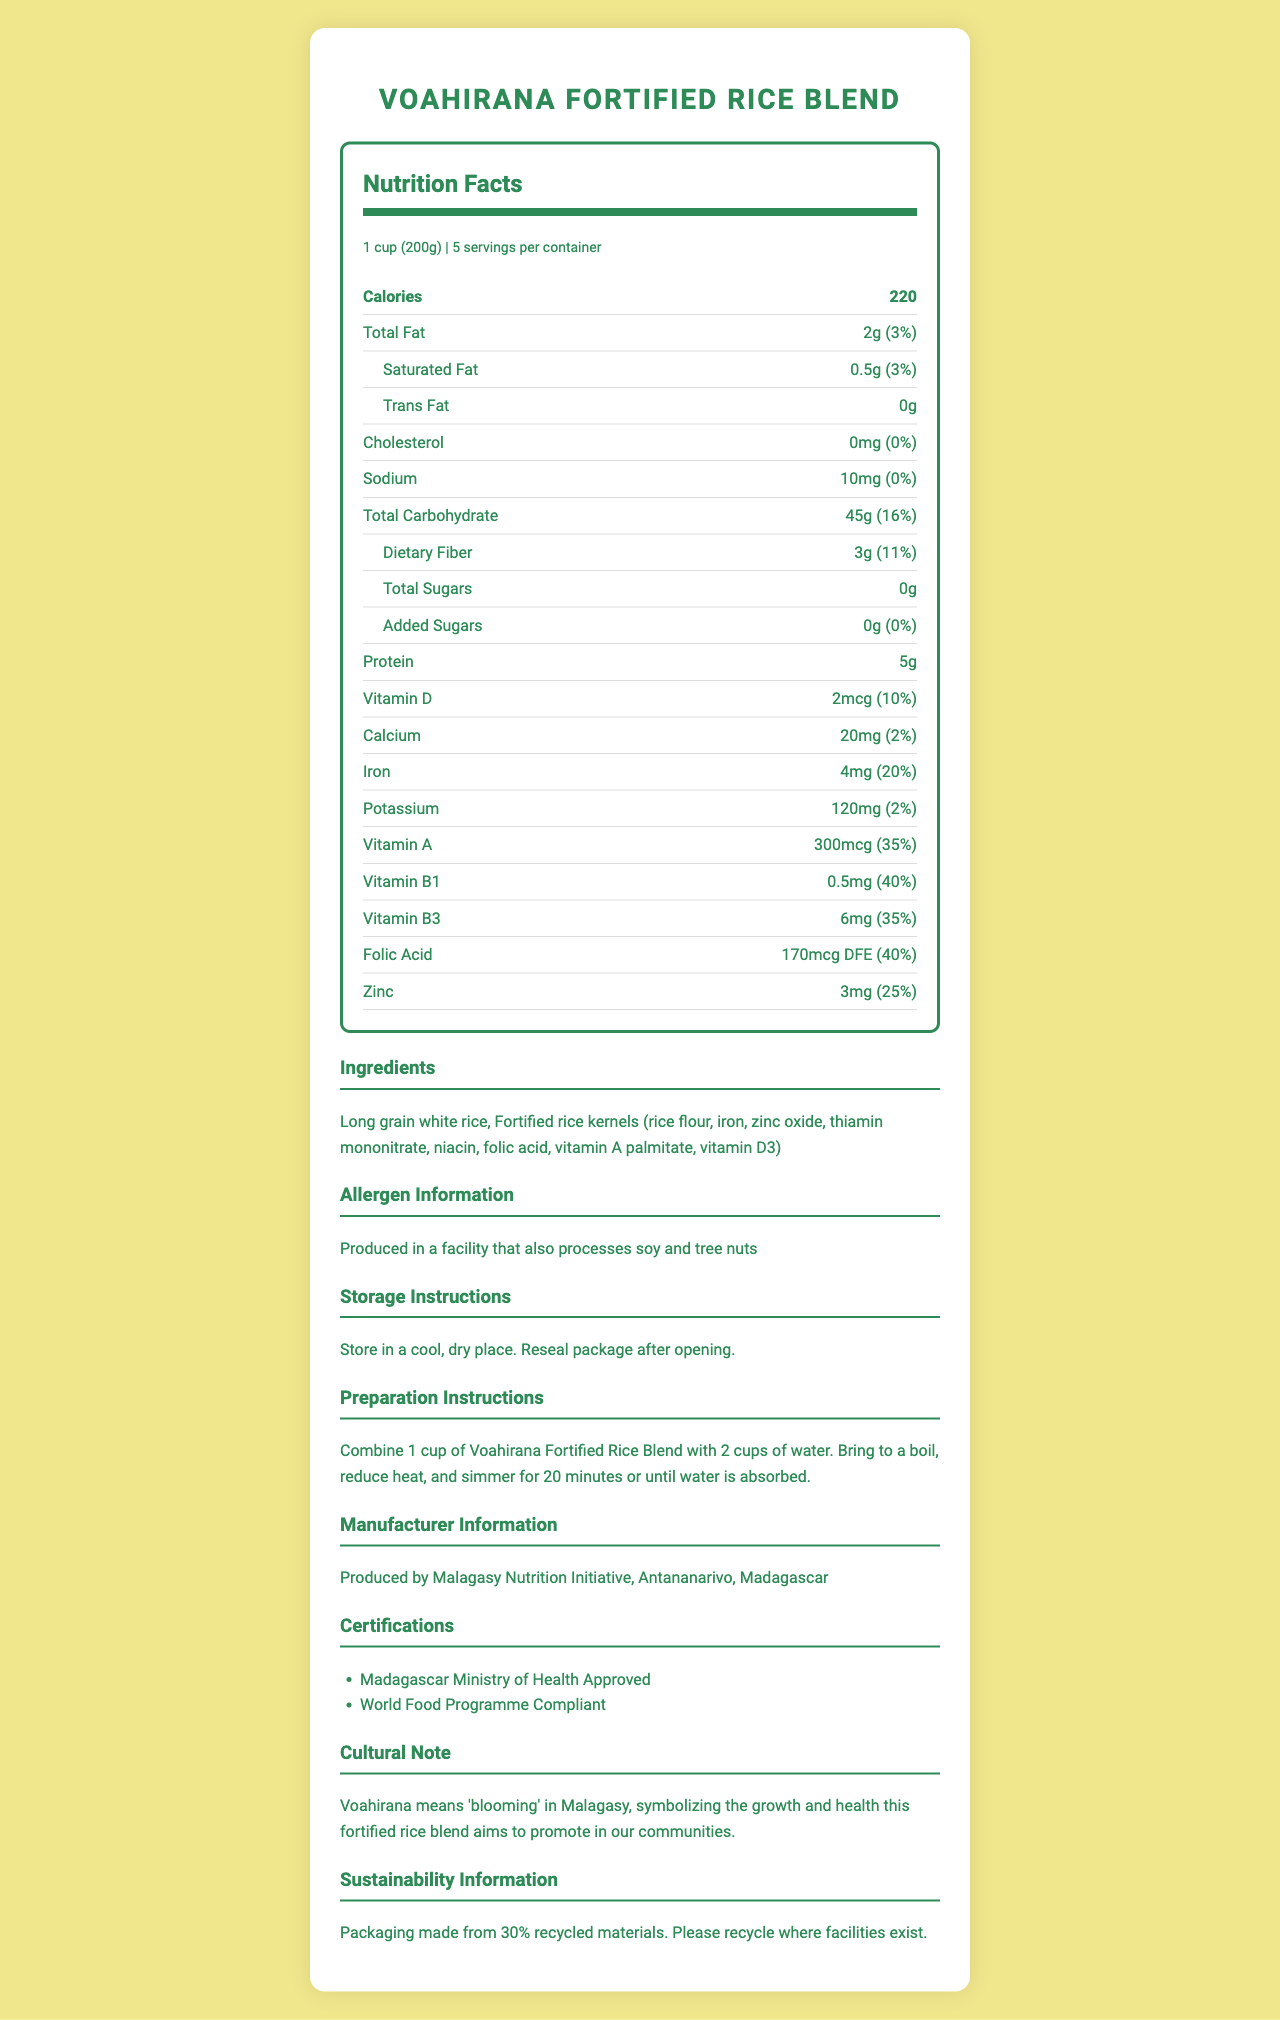what is the serving size? The serving size is mentioned right under the title "Nutrition Facts" as "1 cup (200g)".
Answer: 1 cup (200g) how many calories are in one serving? The calories per serving are listed as 220 right under the serving info.
Answer: 220 calories how much dietary fiber does one serving contain? The amount of dietary fiber per serving is listed under the total carbohydrate section as 3g.
Answer: 3g what percent of the daily value of sodium does one serving have? The percent daily value of sodium per serving is listed under the sodium section as 0%.
Answer: 0% which vitamin has the highest daily value percentage in this product? Among all listed vitamins and minerals, Vitamin B1 has the highest daily value percentage at 40%.
Answer: Vitamin B1 what are the main ingredients in the Voahirana Fortified Rice Blend? The ingredients listed include long grain white rice and fortified rice kernels with various vitamins and minerals.
Answer: Long grain white rice, Fortified rice kernels (rice flour, iron, zinc oxide, thiamin mononitrate, niacin, folic acid, vitamin A palmitate, vitamin D3) how should this product be stored? The storage instructions are clearly mentioned in the section titled "Storage Instructions".
Answer: Store in a cool, dry place. Reseal package after opening. what is the main certification for this product? A. Madagascar Ministry of Health Approved B. USDA Organic C. FDA Approved The nutrition label lists "Madagascar Ministry of Health Approved" and "World Food Programme Compliant" under certifications, but the keyword "main" points to the first listed, which is "Madagascar Ministry of Health Approved."
Answer: A. Madagascar Ministry of Health Approved how much iron is provided per serving? A. 2mg B. 4mg C. 6mg D. 8mg Under the iron section, it lists 4mg per serving.
Answer: B. 4mg is there any cholesterol in this product? It lists cholesterol as "0mg" and the daily value as "0%".
Answer: No what does the cultural note say about the meaning of "Voahirana"? The cultural note section provides this meaning and symbolism.
Answer: Voahirana means 'blooming' in Malagasy, symbolizing growth and health. does this product contain any added sugars? The added sugars section lists "0g" and "0%" for daily value.
Answer: No summarize the purpose and main benefits of Voahirana Fortified Rice Blend This fortified rice blend focuses on delivering better nutrition through essential vitamins and minerals, is compliant with health and food programs, and is culturally significant.
Answer: Voahirana Fortified Rice Blend aims to improve nutrition in rural Malagasy communities by providing essential nutrients like iron, zinc, vitamins A, B1, B3, folic acid, and others in a convenient rice blend. It is approved by the Madagascar Ministry of Health and complies with World Food Programme standards. The blend supports growth and health, symbolized by its name, "Voahirana," meaning 'blooming' in Malagasy, and comes with clear storage and preparation instructions. what is the recommended cooking method for this product? The preparation instructions detail this recommended cooking method.
Answer: Combine 1 cup of Voahirana Fortified Rice Blend with 2 cups of water. Bring to a boil, reduce heat, and simmer for 20 minutes or until water is absorbed. is the Voahirana Fortified Rice Blend certified by the USDA? The document doesn't mention any USDA certification; it only mentions certifications by the Madagascar Ministry of Health and World Food Programme.
Answer: Not enough information 